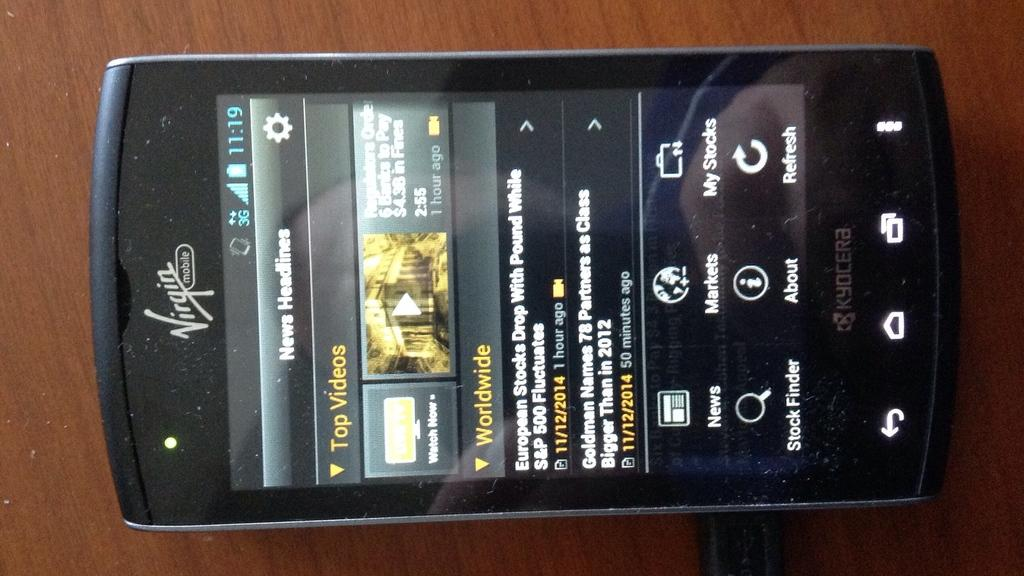<image>
Render a clear and concise summary of the photo. The News Headlines are displayed on a Virgin Mobile phone. 